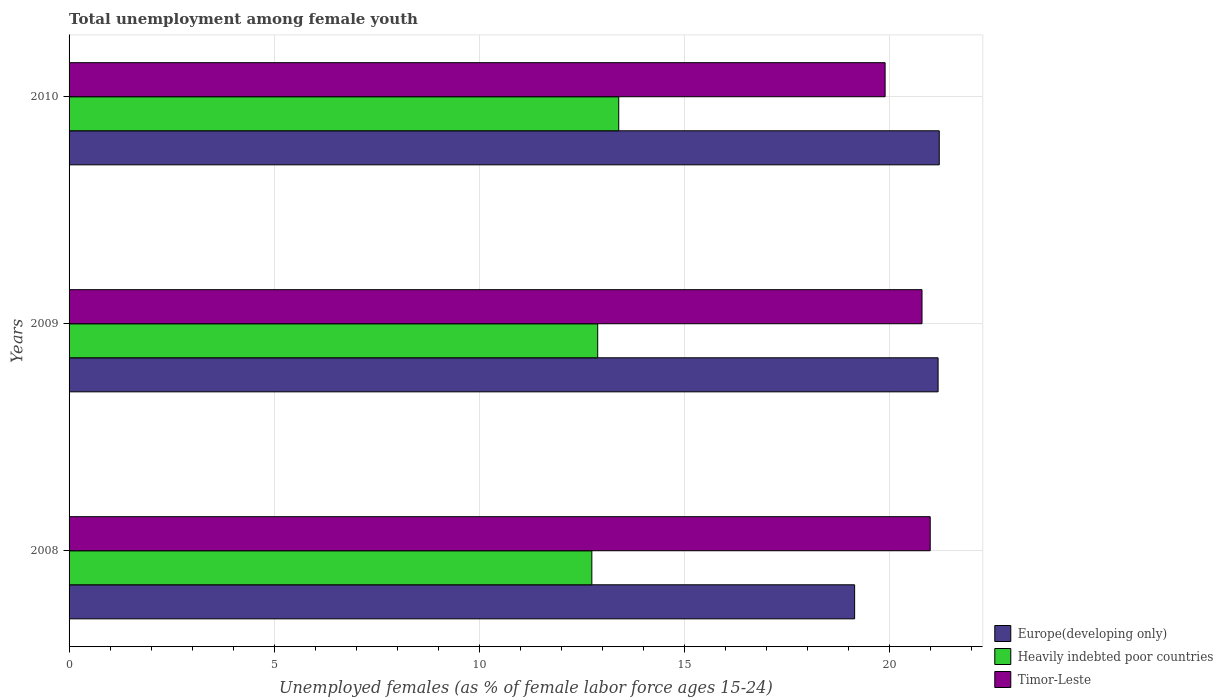How many different coloured bars are there?
Provide a succinct answer. 3. What is the label of the 3rd group of bars from the top?
Provide a succinct answer. 2008. What is the percentage of unemployed females in in Heavily indebted poor countries in 2009?
Keep it short and to the point. 12.89. Across all years, what is the minimum percentage of unemployed females in in Europe(developing only)?
Make the answer very short. 19.16. What is the total percentage of unemployed females in in Timor-Leste in the graph?
Keep it short and to the point. 61.7. What is the difference between the percentage of unemployed females in in Heavily indebted poor countries in 2008 and that in 2009?
Give a very brief answer. -0.14. What is the difference between the percentage of unemployed females in in Timor-Leste in 2010 and the percentage of unemployed females in in Europe(developing only) in 2008?
Offer a terse response. 0.74. What is the average percentage of unemployed females in in Europe(developing only) per year?
Keep it short and to the point. 20.52. In the year 2008, what is the difference between the percentage of unemployed females in in Timor-Leste and percentage of unemployed females in in Heavily indebted poor countries?
Give a very brief answer. 8.25. What is the ratio of the percentage of unemployed females in in Timor-Leste in 2008 to that in 2009?
Your answer should be very brief. 1.01. Is the percentage of unemployed females in in Europe(developing only) in 2009 less than that in 2010?
Offer a very short reply. Yes. Is the difference between the percentage of unemployed females in in Timor-Leste in 2008 and 2009 greater than the difference between the percentage of unemployed females in in Heavily indebted poor countries in 2008 and 2009?
Keep it short and to the point. Yes. What is the difference between the highest and the second highest percentage of unemployed females in in Timor-Leste?
Offer a very short reply. 0.2. What is the difference between the highest and the lowest percentage of unemployed females in in Europe(developing only)?
Your answer should be compact. 2.06. In how many years, is the percentage of unemployed females in in Europe(developing only) greater than the average percentage of unemployed females in in Europe(developing only) taken over all years?
Make the answer very short. 2. What does the 1st bar from the top in 2008 represents?
Ensure brevity in your answer.  Timor-Leste. What does the 2nd bar from the bottom in 2010 represents?
Your answer should be very brief. Heavily indebted poor countries. Is it the case that in every year, the sum of the percentage of unemployed females in in Europe(developing only) and percentage of unemployed females in in Timor-Leste is greater than the percentage of unemployed females in in Heavily indebted poor countries?
Give a very brief answer. Yes. Are all the bars in the graph horizontal?
Provide a succinct answer. Yes. What is the difference between two consecutive major ticks on the X-axis?
Offer a terse response. 5. Does the graph contain any zero values?
Offer a terse response. No. What is the title of the graph?
Provide a short and direct response. Total unemployment among female youth. What is the label or title of the X-axis?
Your response must be concise. Unemployed females (as % of female labor force ages 15-24). What is the label or title of the Y-axis?
Your response must be concise. Years. What is the Unemployed females (as % of female labor force ages 15-24) of Europe(developing only) in 2008?
Your answer should be very brief. 19.16. What is the Unemployed females (as % of female labor force ages 15-24) in Heavily indebted poor countries in 2008?
Your response must be concise. 12.75. What is the Unemployed females (as % of female labor force ages 15-24) of Europe(developing only) in 2009?
Provide a short and direct response. 21.19. What is the Unemployed females (as % of female labor force ages 15-24) of Heavily indebted poor countries in 2009?
Provide a succinct answer. 12.89. What is the Unemployed females (as % of female labor force ages 15-24) in Timor-Leste in 2009?
Provide a short and direct response. 20.8. What is the Unemployed females (as % of female labor force ages 15-24) of Europe(developing only) in 2010?
Provide a succinct answer. 21.22. What is the Unemployed females (as % of female labor force ages 15-24) in Heavily indebted poor countries in 2010?
Provide a short and direct response. 13.4. What is the Unemployed females (as % of female labor force ages 15-24) in Timor-Leste in 2010?
Offer a terse response. 19.9. Across all years, what is the maximum Unemployed females (as % of female labor force ages 15-24) in Europe(developing only)?
Keep it short and to the point. 21.22. Across all years, what is the maximum Unemployed females (as % of female labor force ages 15-24) in Heavily indebted poor countries?
Offer a terse response. 13.4. Across all years, what is the minimum Unemployed females (as % of female labor force ages 15-24) in Europe(developing only)?
Offer a terse response. 19.16. Across all years, what is the minimum Unemployed females (as % of female labor force ages 15-24) of Heavily indebted poor countries?
Your answer should be very brief. 12.75. Across all years, what is the minimum Unemployed females (as % of female labor force ages 15-24) in Timor-Leste?
Ensure brevity in your answer.  19.9. What is the total Unemployed females (as % of female labor force ages 15-24) of Europe(developing only) in the graph?
Your answer should be compact. 61.57. What is the total Unemployed females (as % of female labor force ages 15-24) of Heavily indebted poor countries in the graph?
Offer a very short reply. 39.04. What is the total Unemployed females (as % of female labor force ages 15-24) in Timor-Leste in the graph?
Ensure brevity in your answer.  61.7. What is the difference between the Unemployed females (as % of female labor force ages 15-24) of Europe(developing only) in 2008 and that in 2009?
Your answer should be compact. -2.04. What is the difference between the Unemployed females (as % of female labor force ages 15-24) of Heavily indebted poor countries in 2008 and that in 2009?
Provide a short and direct response. -0.14. What is the difference between the Unemployed females (as % of female labor force ages 15-24) in Timor-Leste in 2008 and that in 2009?
Your response must be concise. 0.2. What is the difference between the Unemployed females (as % of female labor force ages 15-24) in Europe(developing only) in 2008 and that in 2010?
Give a very brief answer. -2.06. What is the difference between the Unemployed females (as % of female labor force ages 15-24) of Heavily indebted poor countries in 2008 and that in 2010?
Your answer should be compact. -0.66. What is the difference between the Unemployed females (as % of female labor force ages 15-24) of Europe(developing only) in 2009 and that in 2010?
Offer a very short reply. -0.03. What is the difference between the Unemployed females (as % of female labor force ages 15-24) of Heavily indebted poor countries in 2009 and that in 2010?
Your answer should be compact. -0.51. What is the difference between the Unemployed females (as % of female labor force ages 15-24) in Timor-Leste in 2009 and that in 2010?
Make the answer very short. 0.9. What is the difference between the Unemployed females (as % of female labor force ages 15-24) of Europe(developing only) in 2008 and the Unemployed females (as % of female labor force ages 15-24) of Heavily indebted poor countries in 2009?
Give a very brief answer. 6.27. What is the difference between the Unemployed females (as % of female labor force ages 15-24) of Europe(developing only) in 2008 and the Unemployed females (as % of female labor force ages 15-24) of Timor-Leste in 2009?
Make the answer very short. -1.64. What is the difference between the Unemployed females (as % of female labor force ages 15-24) in Heavily indebted poor countries in 2008 and the Unemployed females (as % of female labor force ages 15-24) in Timor-Leste in 2009?
Your answer should be very brief. -8.05. What is the difference between the Unemployed females (as % of female labor force ages 15-24) of Europe(developing only) in 2008 and the Unemployed females (as % of female labor force ages 15-24) of Heavily indebted poor countries in 2010?
Your answer should be compact. 5.75. What is the difference between the Unemployed females (as % of female labor force ages 15-24) in Europe(developing only) in 2008 and the Unemployed females (as % of female labor force ages 15-24) in Timor-Leste in 2010?
Provide a short and direct response. -0.74. What is the difference between the Unemployed females (as % of female labor force ages 15-24) of Heavily indebted poor countries in 2008 and the Unemployed females (as % of female labor force ages 15-24) of Timor-Leste in 2010?
Provide a short and direct response. -7.15. What is the difference between the Unemployed females (as % of female labor force ages 15-24) of Europe(developing only) in 2009 and the Unemployed females (as % of female labor force ages 15-24) of Heavily indebted poor countries in 2010?
Provide a short and direct response. 7.79. What is the difference between the Unemployed females (as % of female labor force ages 15-24) in Europe(developing only) in 2009 and the Unemployed females (as % of female labor force ages 15-24) in Timor-Leste in 2010?
Offer a very short reply. 1.29. What is the difference between the Unemployed females (as % of female labor force ages 15-24) of Heavily indebted poor countries in 2009 and the Unemployed females (as % of female labor force ages 15-24) of Timor-Leste in 2010?
Ensure brevity in your answer.  -7.01. What is the average Unemployed females (as % of female labor force ages 15-24) in Europe(developing only) per year?
Keep it short and to the point. 20.52. What is the average Unemployed females (as % of female labor force ages 15-24) in Heavily indebted poor countries per year?
Your response must be concise. 13.01. What is the average Unemployed females (as % of female labor force ages 15-24) of Timor-Leste per year?
Give a very brief answer. 20.57. In the year 2008, what is the difference between the Unemployed females (as % of female labor force ages 15-24) in Europe(developing only) and Unemployed females (as % of female labor force ages 15-24) in Heavily indebted poor countries?
Give a very brief answer. 6.41. In the year 2008, what is the difference between the Unemployed females (as % of female labor force ages 15-24) of Europe(developing only) and Unemployed females (as % of female labor force ages 15-24) of Timor-Leste?
Ensure brevity in your answer.  -1.84. In the year 2008, what is the difference between the Unemployed females (as % of female labor force ages 15-24) of Heavily indebted poor countries and Unemployed females (as % of female labor force ages 15-24) of Timor-Leste?
Make the answer very short. -8.25. In the year 2009, what is the difference between the Unemployed females (as % of female labor force ages 15-24) in Europe(developing only) and Unemployed females (as % of female labor force ages 15-24) in Heavily indebted poor countries?
Your answer should be compact. 8.3. In the year 2009, what is the difference between the Unemployed females (as % of female labor force ages 15-24) in Europe(developing only) and Unemployed females (as % of female labor force ages 15-24) in Timor-Leste?
Your answer should be very brief. 0.39. In the year 2009, what is the difference between the Unemployed females (as % of female labor force ages 15-24) of Heavily indebted poor countries and Unemployed females (as % of female labor force ages 15-24) of Timor-Leste?
Your answer should be very brief. -7.91. In the year 2010, what is the difference between the Unemployed females (as % of female labor force ages 15-24) in Europe(developing only) and Unemployed females (as % of female labor force ages 15-24) in Heavily indebted poor countries?
Keep it short and to the point. 7.82. In the year 2010, what is the difference between the Unemployed females (as % of female labor force ages 15-24) of Europe(developing only) and Unemployed females (as % of female labor force ages 15-24) of Timor-Leste?
Your answer should be very brief. 1.32. In the year 2010, what is the difference between the Unemployed females (as % of female labor force ages 15-24) of Heavily indebted poor countries and Unemployed females (as % of female labor force ages 15-24) of Timor-Leste?
Provide a succinct answer. -6.5. What is the ratio of the Unemployed females (as % of female labor force ages 15-24) in Europe(developing only) in 2008 to that in 2009?
Your answer should be very brief. 0.9. What is the ratio of the Unemployed females (as % of female labor force ages 15-24) in Heavily indebted poor countries in 2008 to that in 2009?
Provide a succinct answer. 0.99. What is the ratio of the Unemployed females (as % of female labor force ages 15-24) of Timor-Leste in 2008 to that in 2009?
Your response must be concise. 1.01. What is the ratio of the Unemployed females (as % of female labor force ages 15-24) of Europe(developing only) in 2008 to that in 2010?
Keep it short and to the point. 0.9. What is the ratio of the Unemployed females (as % of female labor force ages 15-24) in Heavily indebted poor countries in 2008 to that in 2010?
Offer a very short reply. 0.95. What is the ratio of the Unemployed females (as % of female labor force ages 15-24) of Timor-Leste in 2008 to that in 2010?
Offer a terse response. 1.06. What is the ratio of the Unemployed females (as % of female labor force ages 15-24) of Heavily indebted poor countries in 2009 to that in 2010?
Make the answer very short. 0.96. What is the ratio of the Unemployed females (as % of female labor force ages 15-24) in Timor-Leste in 2009 to that in 2010?
Make the answer very short. 1.05. What is the difference between the highest and the second highest Unemployed females (as % of female labor force ages 15-24) of Europe(developing only)?
Ensure brevity in your answer.  0.03. What is the difference between the highest and the second highest Unemployed females (as % of female labor force ages 15-24) of Heavily indebted poor countries?
Ensure brevity in your answer.  0.51. What is the difference between the highest and the lowest Unemployed females (as % of female labor force ages 15-24) in Europe(developing only)?
Offer a very short reply. 2.06. What is the difference between the highest and the lowest Unemployed females (as % of female labor force ages 15-24) in Heavily indebted poor countries?
Your response must be concise. 0.66. What is the difference between the highest and the lowest Unemployed females (as % of female labor force ages 15-24) in Timor-Leste?
Your answer should be compact. 1.1. 